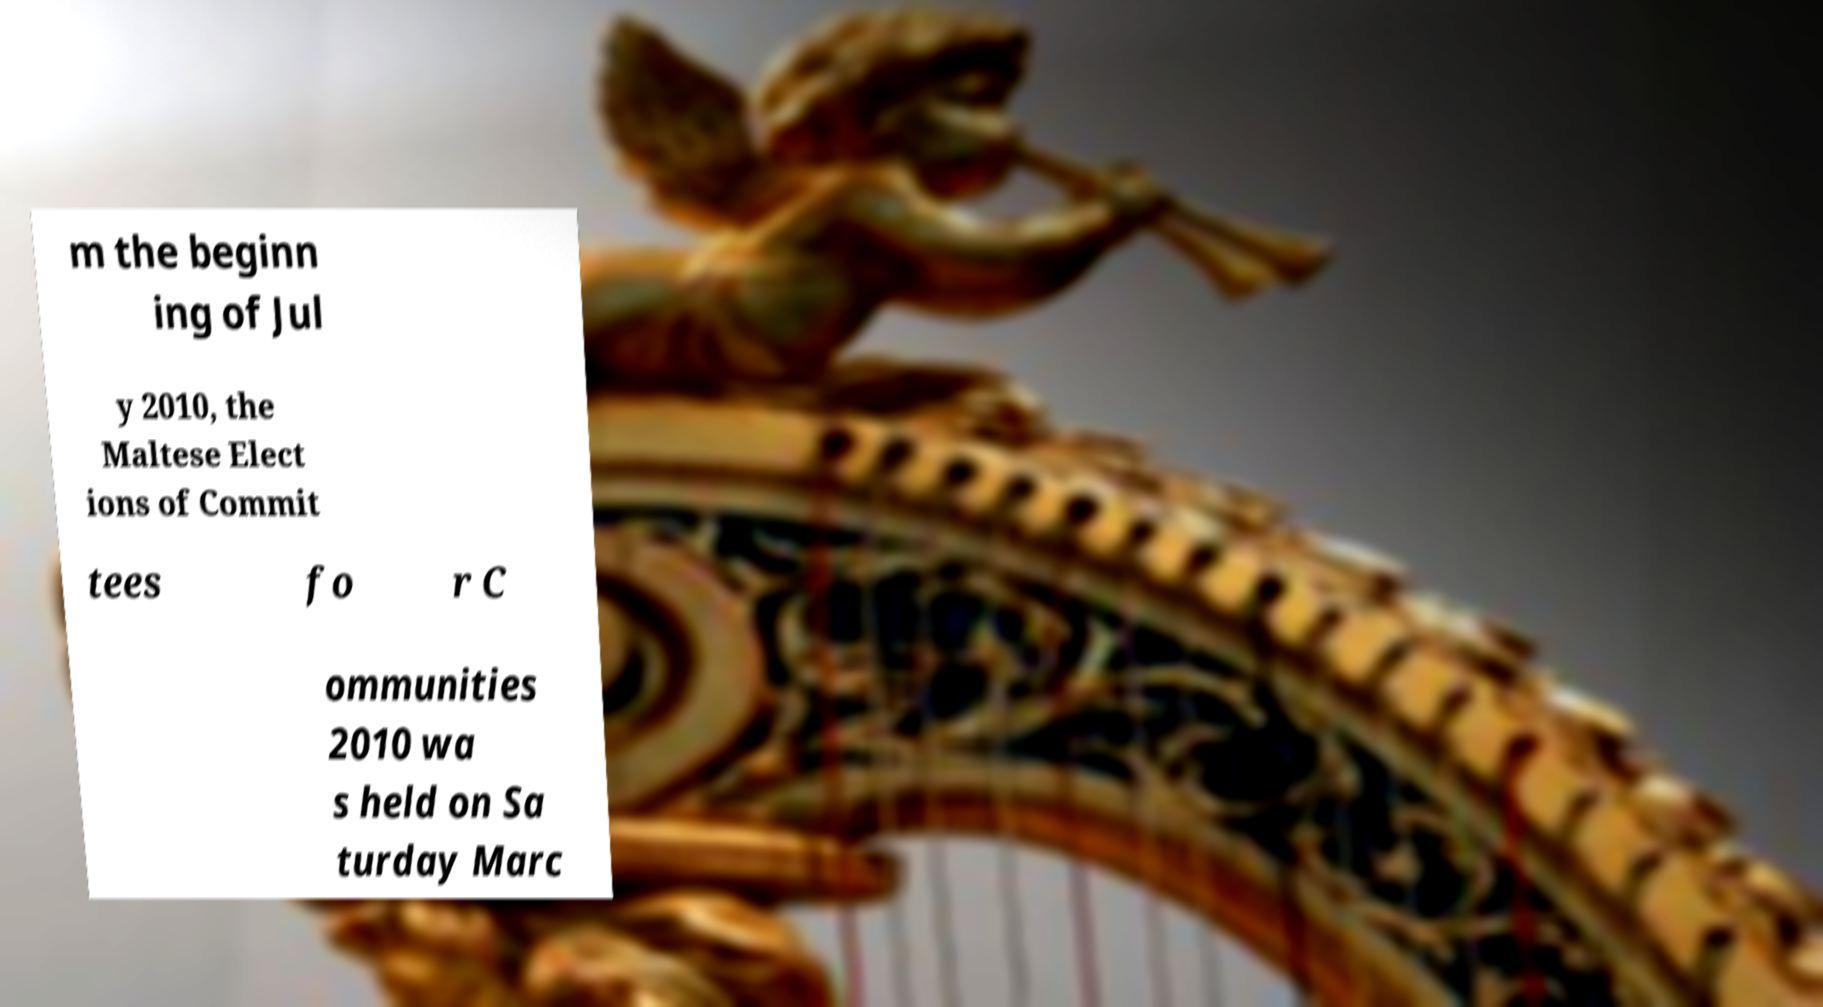I need the written content from this picture converted into text. Can you do that? m the beginn ing of Jul y 2010, the Maltese Elect ions of Commit tees fo r C ommunities 2010 wa s held on Sa turday Marc 